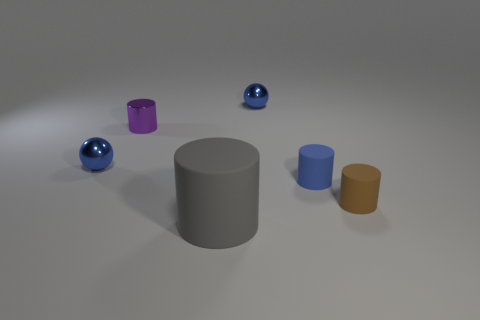Subtract 2 cylinders. How many cylinders are left? 2 Subtract all green cylinders. Subtract all blue spheres. How many cylinders are left? 4 Add 3 large gray rubber cylinders. How many objects exist? 9 Subtract all cylinders. How many objects are left? 2 Add 5 tiny blue rubber cylinders. How many tiny blue rubber cylinders are left? 6 Add 5 tiny purple metallic cylinders. How many tiny purple metallic cylinders exist? 6 Subtract 0 gray cubes. How many objects are left? 6 Subtract all tiny brown matte cylinders. Subtract all brown objects. How many objects are left? 4 